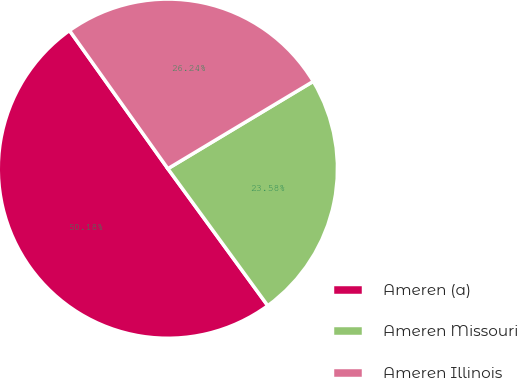Convert chart to OTSL. <chart><loc_0><loc_0><loc_500><loc_500><pie_chart><fcel>Ameren (a)<fcel>Ameren Missouri<fcel>Ameren Illinois<nl><fcel>50.18%<fcel>23.58%<fcel>26.24%<nl></chart> 